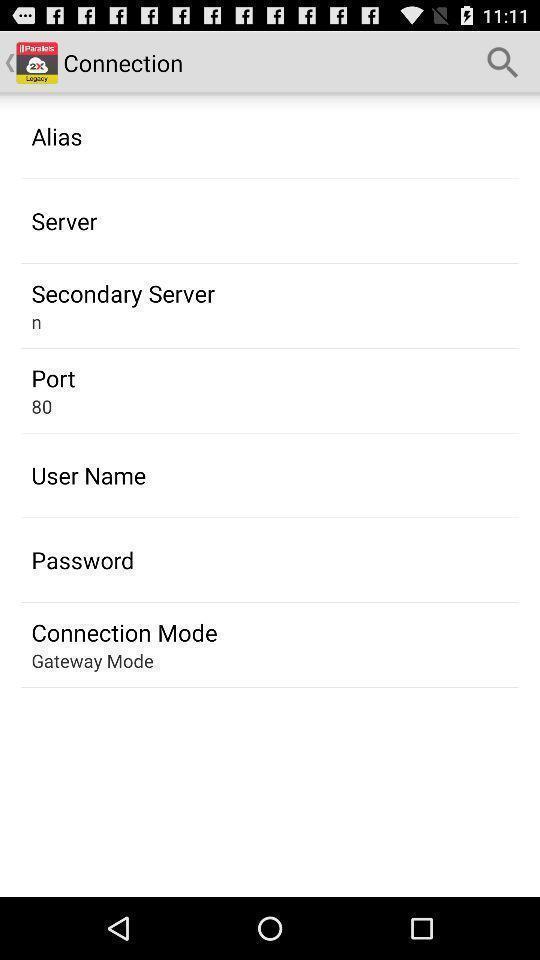Provide a textual representation of this image. Screen shows connection list. 